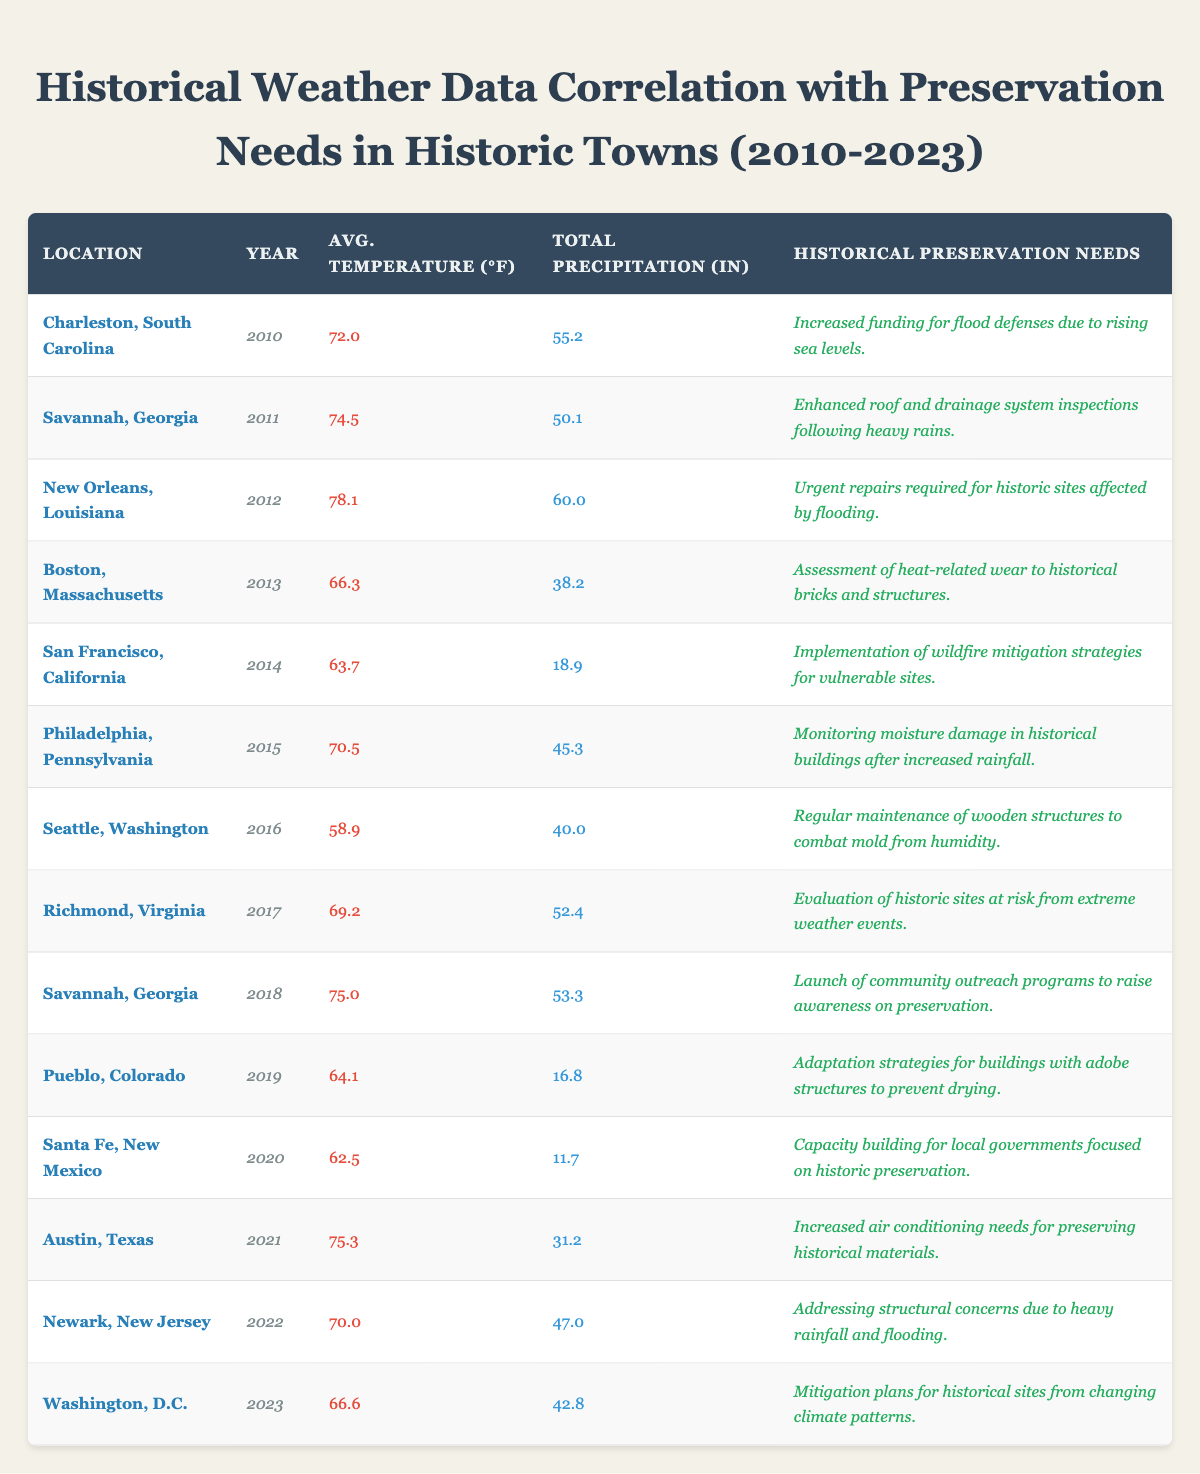What is the historical preservation need listed for New Orleans in 2012? According to the table, for New Orleans, Louisiana in 2012, the historical preservation need is "Urgent repairs required for historic sites affected by flooding."
Answer: Urgent repairs required for historic sites affected by flooding What was the average temperature in Savannah, Georgia in 2011? The table indicates that the average temperature in Savannah, Georgia in 2011 was 74.5°F.
Answer: 74.5°F Which year had the highest total precipitation and what was that amount? Looking at the total precipitation for each year, New Orleans in 2012 had the highest value at 60.0 inches.
Answer: 60.0 inches Was there any mention of moisture damage concerns in historical buildings? Yes, the preservation need for Philadelphia in 2015 mentions "Monitoring moisture damage in historical buildings after increased rainfall."
Answer: Yes What are the preservation needs for locations that experienced significant flooding in both 2012 and 2022? In 2012, New Orleans needed urgent repairs for historic sites affected by flooding. In 2022, Newark faced issues with structural concerns due to heavy rainfall and flooding.
Answer: New Orleans: urgent repairs; Newark: structural concerns How does the average temperature change in Boston from 2013 to 2023 based on the data? The average temperature in Boston in 2013 is 66.3°F, while in 2023, it is 66.6°F. The change is a rise of 0.3°F from 2013 to 2023.
Answer: Increase of 0.3°F What was the total precipitation for Washington, D.C. in 2023 compared to its average temperature? In 2023, Washington, D.C. received total precipitation of 42.8 inches, and the average temperature was 66.6°F. The data provides both figures directly.
Answer: 42.8 inches; 66.6°F Which historic town had the lowest average temperature recorded in this dataset, and what was that temperature? Seattle, Washington in 2016 had the lowest average temperature recorded at 58.9°F.
Answer: 58.9°F Calculate the average temperature across all locations for the year 2018. In 2018, the average temperature for Savannah, Georgia was 75.0°F. There’s only one data point for that year, so the average is 75.0°F.
Answer: 75.0°F Are there any preservation needs related to wildfire in the provided data? Yes, San Francisco, California in 2014 mentions the need for "Implementation of wildfire mitigation strategies for vulnerable sites."
Answer: Yes What is the relationship between higher total precipitation and preservation needs based on this dataset? Examining the dataset shows that locations with higher total precipitation often have more urgent preservation needs, such as those for flood defenses or urgent repairs. For instance, New Orleans and Newark both highlight issues from flooding.
Answer: Higher precipitation correlates with urgent preservation needs 